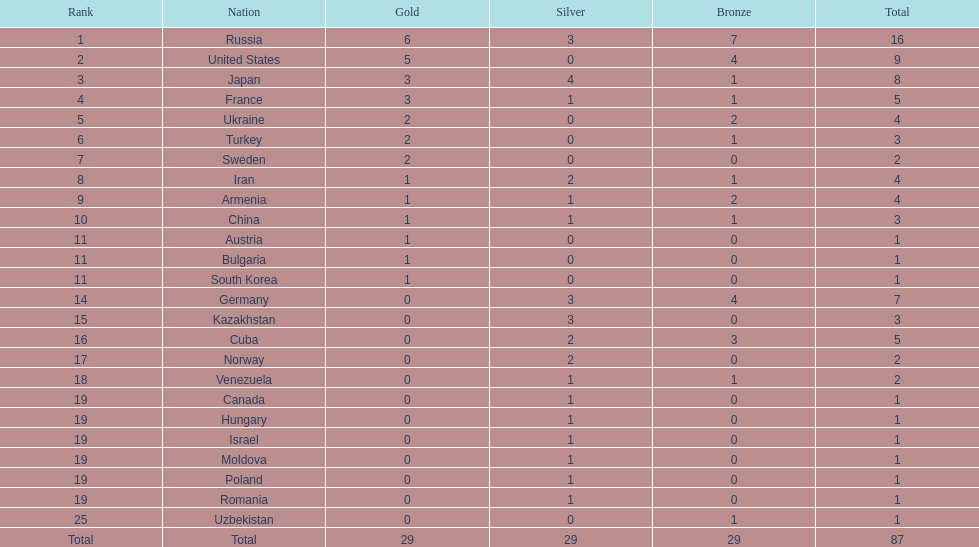Which nation was not in the top 10 iran or germany? Germany. 